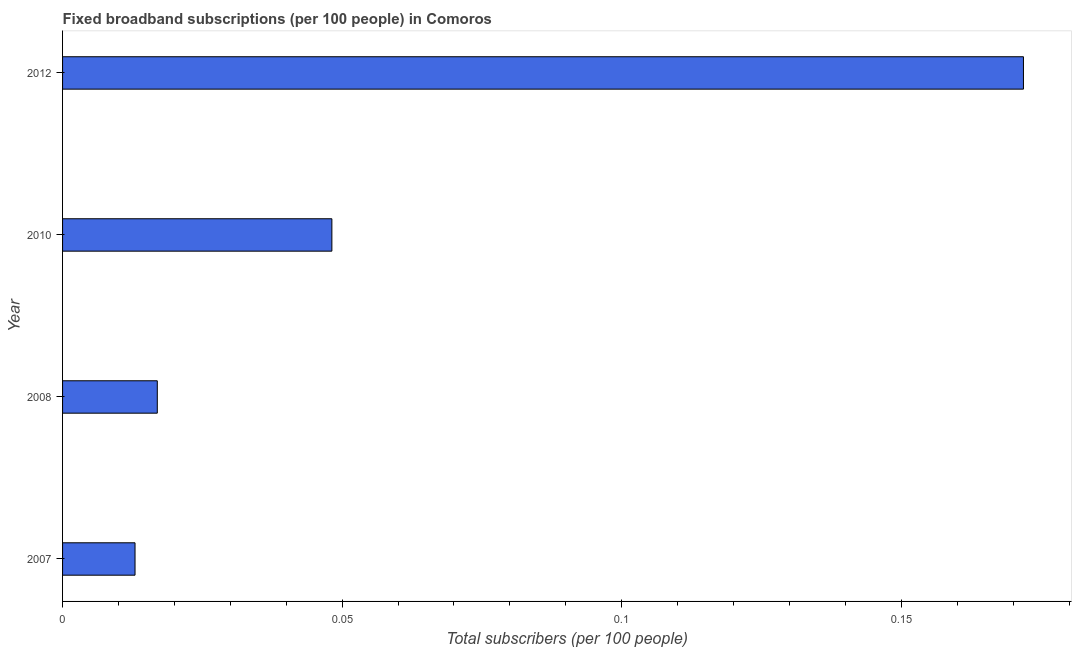Does the graph contain grids?
Provide a succinct answer. No. What is the title of the graph?
Give a very brief answer. Fixed broadband subscriptions (per 100 people) in Comoros. What is the label or title of the X-axis?
Your answer should be compact. Total subscribers (per 100 people). What is the label or title of the Y-axis?
Provide a short and direct response. Year. What is the total number of fixed broadband subscriptions in 2007?
Make the answer very short. 0.01. Across all years, what is the maximum total number of fixed broadband subscriptions?
Make the answer very short. 0.17. Across all years, what is the minimum total number of fixed broadband subscriptions?
Provide a succinct answer. 0.01. In which year was the total number of fixed broadband subscriptions maximum?
Offer a very short reply. 2012. What is the sum of the total number of fixed broadband subscriptions?
Ensure brevity in your answer.  0.25. What is the difference between the total number of fixed broadband subscriptions in 2007 and 2010?
Give a very brief answer. -0.04. What is the average total number of fixed broadband subscriptions per year?
Provide a succinct answer. 0.06. What is the median total number of fixed broadband subscriptions?
Your answer should be compact. 0.03. In how many years, is the total number of fixed broadband subscriptions greater than 0.03 ?
Your response must be concise. 2. Do a majority of the years between 2007 and 2012 (inclusive) have total number of fixed broadband subscriptions greater than 0.17 ?
Provide a short and direct response. No. What is the ratio of the total number of fixed broadband subscriptions in 2007 to that in 2012?
Make the answer very short. 0.07. Is the total number of fixed broadband subscriptions in 2007 less than that in 2008?
Your answer should be very brief. Yes. What is the difference between the highest and the second highest total number of fixed broadband subscriptions?
Keep it short and to the point. 0.12. What is the difference between the highest and the lowest total number of fixed broadband subscriptions?
Provide a succinct answer. 0.16. How many bars are there?
Provide a short and direct response. 4. How many years are there in the graph?
Your answer should be very brief. 4. Are the values on the major ticks of X-axis written in scientific E-notation?
Your response must be concise. No. What is the Total subscribers (per 100 people) in 2007?
Keep it short and to the point. 0.01. What is the Total subscribers (per 100 people) in 2008?
Your answer should be very brief. 0.02. What is the Total subscribers (per 100 people) of 2010?
Provide a short and direct response. 0.05. What is the Total subscribers (per 100 people) of 2012?
Keep it short and to the point. 0.17. What is the difference between the Total subscribers (per 100 people) in 2007 and 2008?
Give a very brief answer. -0. What is the difference between the Total subscribers (per 100 people) in 2007 and 2010?
Keep it short and to the point. -0.04. What is the difference between the Total subscribers (per 100 people) in 2007 and 2012?
Make the answer very short. -0.16. What is the difference between the Total subscribers (per 100 people) in 2008 and 2010?
Make the answer very short. -0.03. What is the difference between the Total subscribers (per 100 people) in 2008 and 2012?
Your answer should be very brief. -0.15. What is the difference between the Total subscribers (per 100 people) in 2010 and 2012?
Provide a succinct answer. -0.12. What is the ratio of the Total subscribers (per 100 people) in 2007 to that in 2008?
Give a very brief answer. 0.77. What is the ratio of the Total subscribers (per 100 people) in 2007 to that in 2010?
Give a very brief answer. 0.27. What is the ratio of the Total subscribers (per 100 people) in 2007 to that in 2012?
Your answer should be very brief. 0.07. What is the ratio of the Total subscribers (per 100 people) in 2008 to that in 2010?
Offer a terse response. 0.35. What is the ratio of the Total subscribers (per 100 people) in 2008 to that in 2012?
Provide a succinct answer. 0.1. What is the ratio of the Total subscribers (per 100 people) in 2010 to that in 2012?
Ensure brevity in your answer.  0.28. 